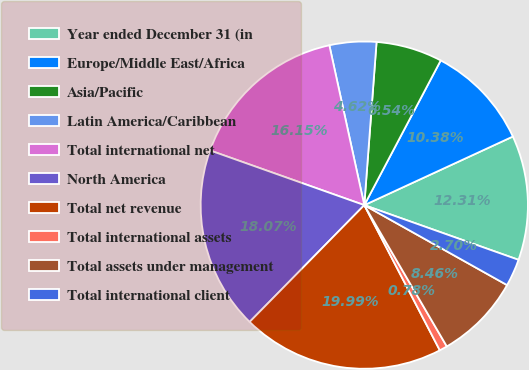<chart> <loc_0><loc_0><loc_500><loc_500><pie_chart><fcel>Year ended December 31 (in<fcel>Europe/Middle East/Africa<fcel>Asia/Pacific<fcel>Latin America/Caribbean<fcel>Total international net<fcel>North America<fcel>Total net revenue<fcel>Total international assets<fcel>Total assets under management<fcel>Total international client<nl><fcel>12.31%<fcel>10.38%<fcel>6.54%<fcel>4.62%<fcel>16.15%<fcel>18.07%<fcel>19.99%<fcel>0.78%<fcel>8.46%<fcel>2.7%<nl></chart> 